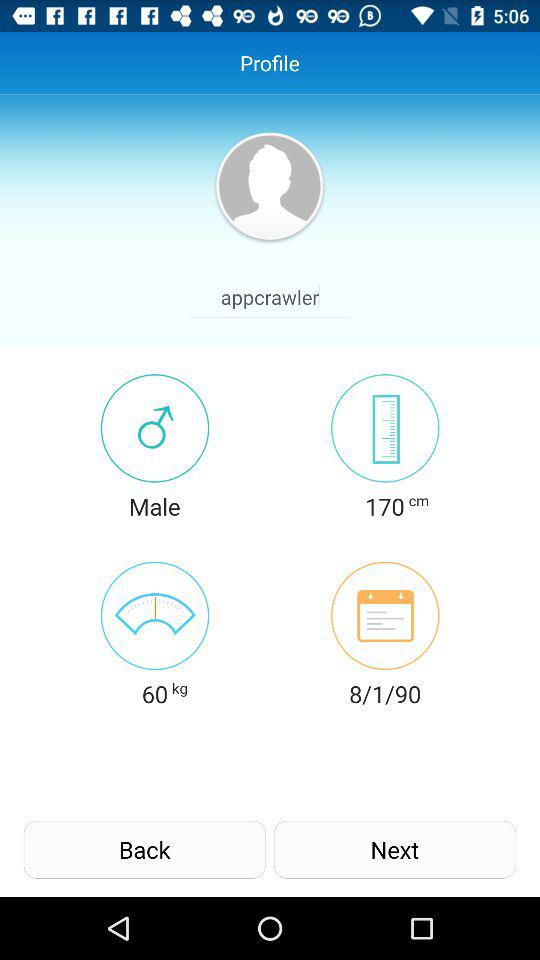What is the name of the user? The name of the user is Appcrawler. 